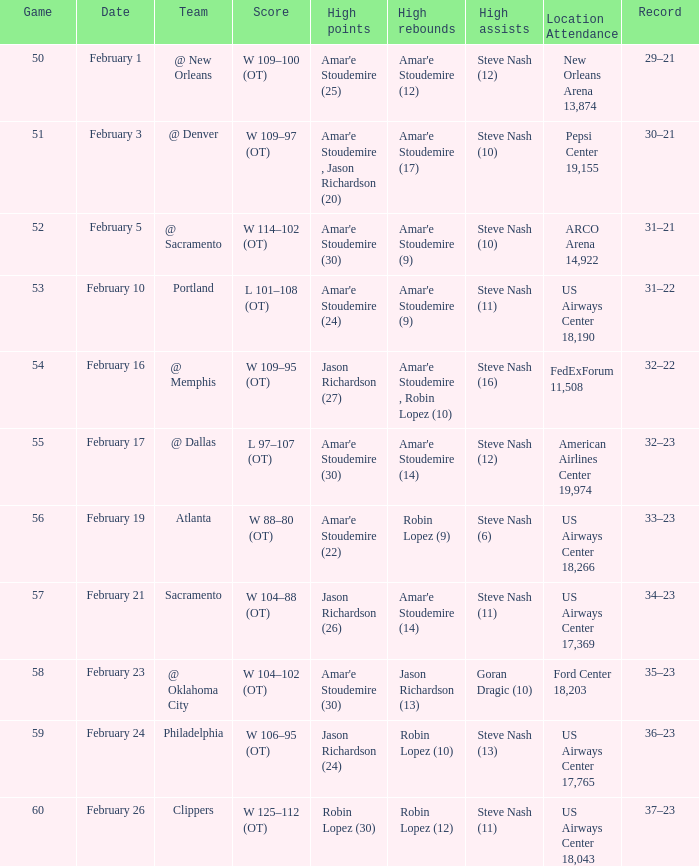Identify the top features of the 19,155-seat pepsi center. Amar'e Stoudemire , Jason Richardson (20). 